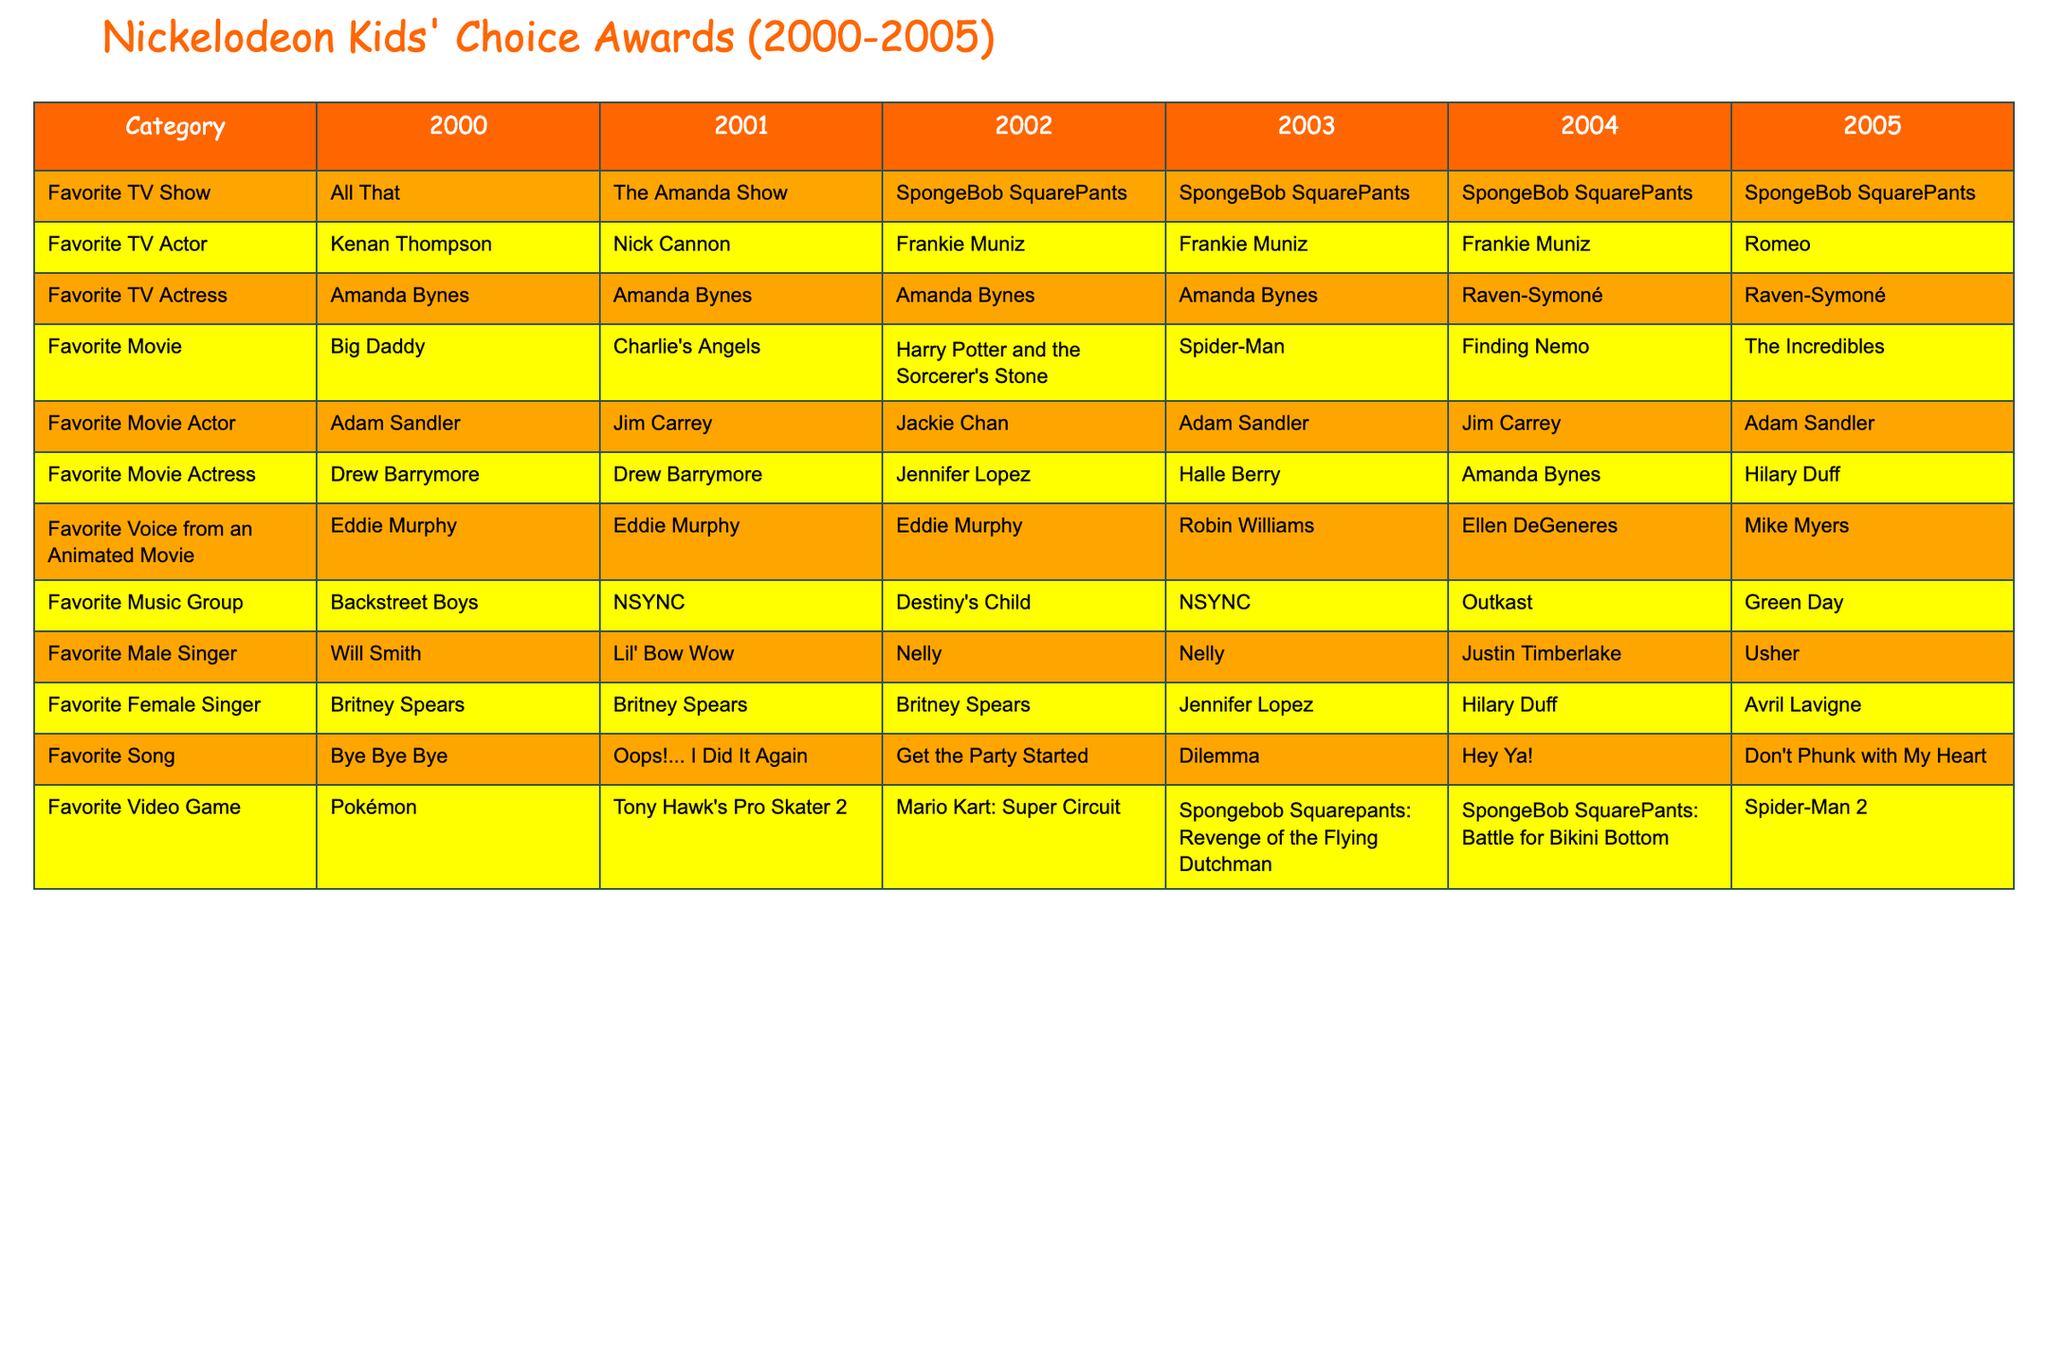What was the favorite TV show in 2000? The table lists the favorite TV shows for each year. In the year 2000, the favorite TV show was "All That."
Answer: All That Which movie actress won in 2005? According to the table, the favorite movie actress for 2005 is Hilary Duff.
Answer: Hilary Duff How many times did "SpongeBob SquarePants" win for Favorite TV Show from 2000 to 2005? By reviewing the table, "SpongeBob SquarePants" won for Favorite TV Show in 2003, 2004, and 2005, totalling 3 times.
Answer: 3 Who was the Favorite Male Singer in 2004? The table indicates that for 2004, the favorite male singer was Justin Timberlake.
Answer: Justin Timberlake What is the difference in favorite movie actress between 2002 and 2004? The favorite movie actress in 2002 was Jennifer Lopez and in 2004 was Amanda Bynes. To find the difference, we first note their names: (Jennifer Lopez vs. Amanda Bynes). The question is about names, so we see that it changed.
Answer: The favorite movie actress changed Which animated movie voice actor had the most wins between 2000 to 2005? By checking the table, Eddie Murphy won for Favorite Voice from an Animated Movie from 2000 to 2002, and then Robin Williams won in 2003. From 2004 onwards, Ellen DeGeneres and Mike Myers won once. Therefore, Eddie Murphy has 3 wins.
Answer: Eddie Murphy Did the Favorite Video Game change from 2000 to 2005? By looking at the table from 2000 to 2005, we see the games listed are Pokemon, Tony Hawk's Pro Skater 2, Mario Kart: Super Circuit, SpongeBob SquarePants: Revenge of the Flying Dutchman, SpongeBob SquarePants: Battle for Bikini Bottom, and Spider-Man 2. There are different games listed each year, confirming a change.
Answer: Yes Calculate the average favorite song title character length from 2000 to 2005. To find the average song title character length, first, we count the characters: "Bye Bye Bye" (11), "Oops!... I Did It Again" (20), "Get the Party Started" (18), "Dilemma" (7), "Hey Ya!" (7), "Don't Phunk with My Heart" (22). The total length is 105 characters over 6 titles, giving an average of 105/6.
Answer: 17.5 What trend do you see in the Favorite TV Actress category from 2000 to 2005? A trend observed in the table is that Amanda Bynes won for Favorite TV Actress for 2000 to 2004, and in 2005, the winner changed to Raven-Symoné. This indicates Amanda's dominance in the early years followed by a shift in 2005.
Answer: Dominance by Amanda Bynes, then a shift in 2005 